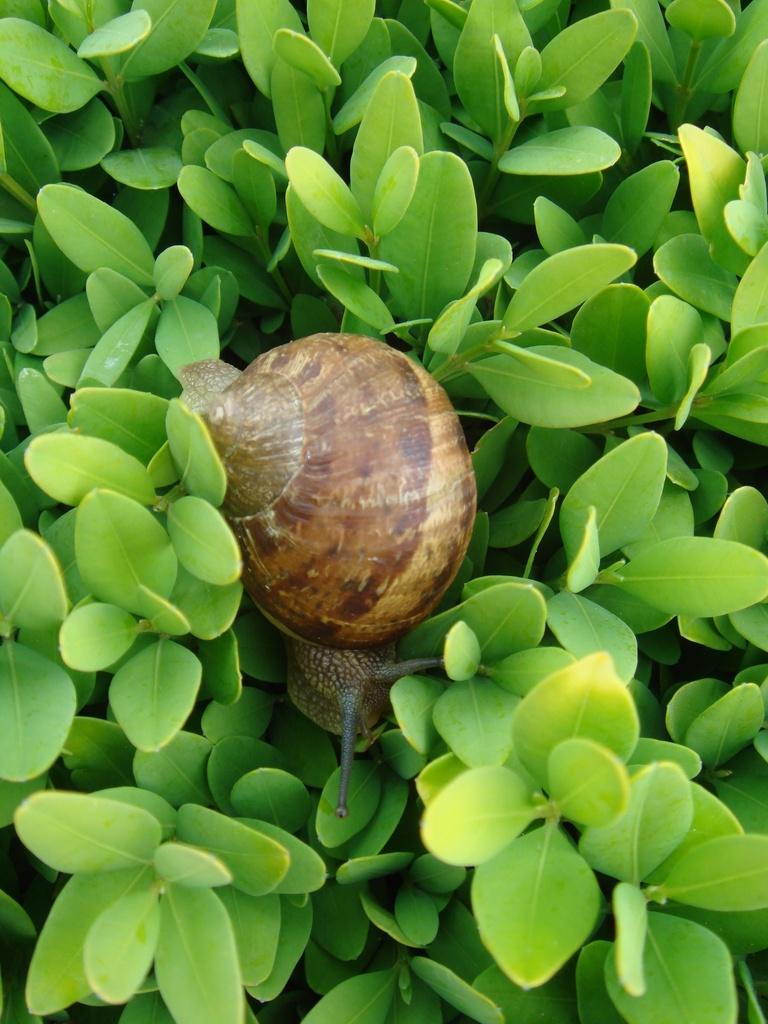What type of living organisms can be seen in the image? Plants and a snail can be seen in the image. What other object is present in the image? There is a shell in the image. What type of furniture can be seen in the image? There is no furniture present in the image; it features plants, a snail, and a shell. Are there any police officers visible in the image? There are no police officers present in the image. Can you see any baseball equipment in the image? There is no baseball equipment present in the image. 